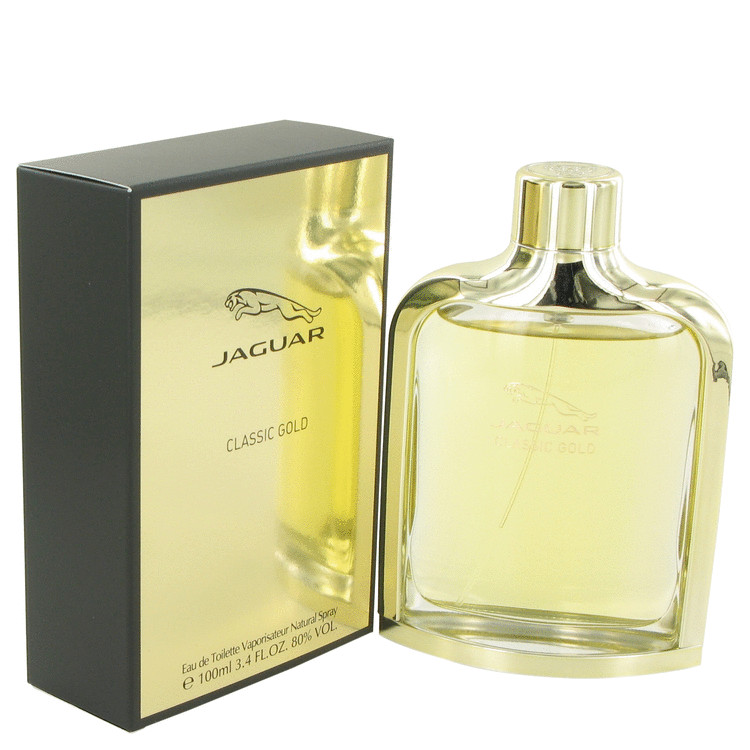Describe the visual appeal of this perfume packaging and its potential impact on a consumer’s purchasing decision. The perfume packaging has a striking visual appeal, primarily due to the use of gold and black elements. The gold color exudes a sense of luxury and opulence, making the product feel premium and exclusive. The matte black background adds a layer of sophistication and modernity, creating a visually appealing contrast. The sleek, reflective surface of the gold further draws attention, helping the product stand out on the shelf. This combination of luxury, sophistication, and visual prominence is likely to make a strong impression on consumers, influencing their perception of the perfume as a high-quality and desirable item. How does the design of the bottle complement the packaging in conveying the brand's message? The design of the bottle seamlessly complements the packaging, enhancing the brand's message of luxury and sophistication. The bottle’s sleek and elegant shape aligns with the premium gold and black color scheme of the packaging. The use of clear glass allows the golden hue of the perfume to be a focal point, adding to the luxurious appeal. The minimalist design of the bottle, devoid of excessive decorations, suggests timeless elegance and classic refinement. This harmony between the bottle and the packaging reinforces the brand's aim to project an image of high quality, exclusivity, and understated luxury. Can you imagine a scenario in which this perfume could be a perfect gift? Describe it in detail. Imagine a sophisticated evening gathering in a luxurious city penthouse, with the skyline lit up in the background. A host has invited close friends and family to celebrate a special milestone, perhaps a significant career achievement or an anniversary. Among the carefully selected gifts, this perfume stands out, beautifully wrapped in black and gold paper to match the packaging. As the host opens the gift, the guests are captivated by the elegant and luxurious presentation of the perfume. The gold and matte black packaging exudes a sense of exclusivity and thoughtfulness, ideal for this elegant occasion. The perfume is revealed to murmurs of appreciation, as its refined design aligns perfectly with the sophistication of the event. This thoughtful and premium gift not only conveys the giver's appreciation and celebration of the host's milestone but also adds a touch of luxury to an already exquisite evening. 